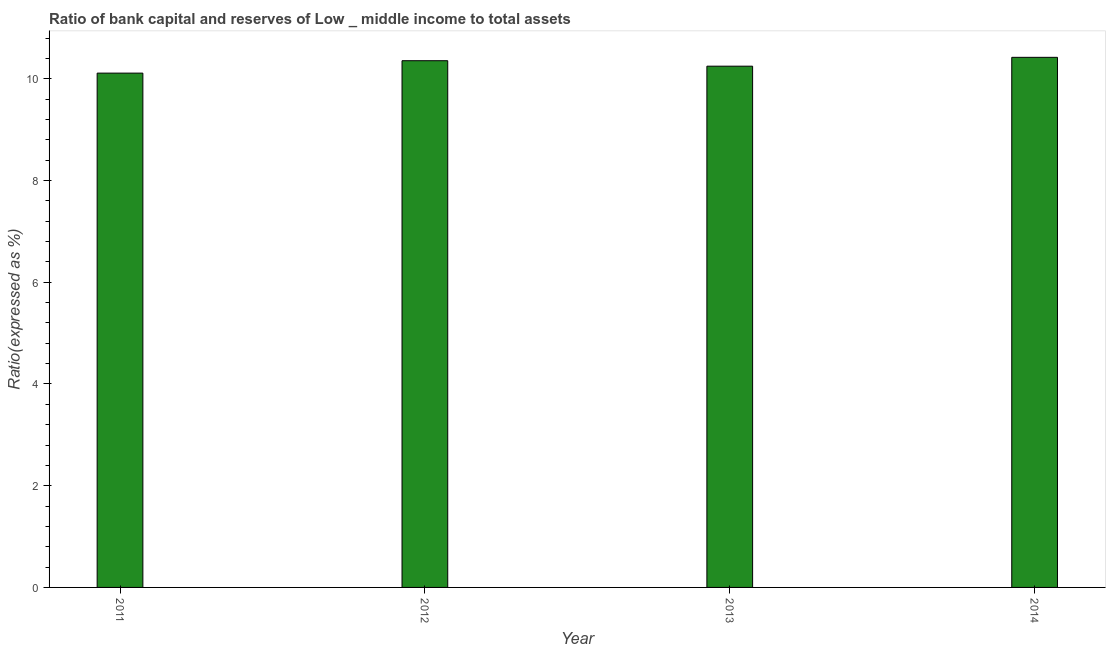Does the graph contain any zero values?
Offer a terse response. No. What is the title of the graph?
Your answer should be very brief. Ratio of bank capital and reserves of Low _ middle income to total assets. What is the label or title of the Y-axis?
Offer a very short reply. Ratio(expressed as %). What is the bank capital to assets ratio in 2012?
Give a very brief answer. 10.36. Across all years, what is the maximum bank capital to assets ratio?
Provide a succinct answer. 10.42. Across all years, what is the minimum bank capital to assets ratio?
Give a very brief answer. 10.11. What is the sum of the bank capital to assets ratio?
Offer a terse response. 41.14. What is the difference between the bank capital to assets ratio in 2011 and 2012?
Ensure brevity in your answer.  -0.24. What is the average bank capital to assets ratio per year?
Offer a terse response. 10.29. What is the median bank capital to assets ratio?
Keep it short and to the point. 10.3. Do a majority of the years between 2011 and 2013 (inclusive) have bank capital to assets ratio greater than 7.6 %?
Provide a short and direct response. Yes. What is the ratio of the bank capital to assets ratio in 2012 to that in 2014?
Your answer should be very brief. 0.99. Is the bank capital to assets ratio in 2011 less than that in 2012?
Provide a short and direct response. Yes. Is the difference between the bank capital to assets ratio in 2012 and 2013 greater than the difference between any two years?
Offer a terse response. No. What is the difference between the highest and the second highest bank capital to assets ratio?
Make the answer very short. 0.07. What is the difference between the highest and the lowest bank capital to assets ratio?
Make the answer very short. 0.31. How many years are there in the graph?
Keep it short and to the point. 4. What is the Ratio(expressed as %) of 2011?
Your answer should be compact. 10.11. What is the Ratio(expressed as %) in 2012?
Keep it short and to the point. 10.36. What is the Ratio(expressed as %) of 2013?
Your answer should be very brief. 10.25. What is the Ratio(expressed as %) in 2014?
Offer a very short reply. 10.42. What is the difference between the Ratio(expressed as %) in 2011 and 2012?
Ensure brevity in your answer.  -0.24. What is the difference between the Ratio(expressed as %) in 2011 and 2013?
Your answer should be very brief. -0.14. What is the difference between the Ratio(expressed as %) in 2011 and 2014?
Make the answer very short. -0.31. What is the difference between the Ratio(expressed as %) in 2012 and 2013?
Keep it short and to the point. 0.11. What is the difference between the Ratio(expressed as %) in 2012 and 2014?
Give a very brief answer. -0.07. What is the difference between the Ratio(expressed as %) in 2013 and 2014?
Your response must be concise. -0.17. What is the ratio of the Ratio(expressed as %) in 2011 to that in 2013?
Your answer should be very brief. 0.99. What is the ratio of the Ratio(expressed as %) in 2011 to that in 2014?
Ensure brevity in your answer.  0.97. What is the ratio of the Ratio(expressed as %) in 2012 to that in 2014?
Give a very brief answer. 0.99. 